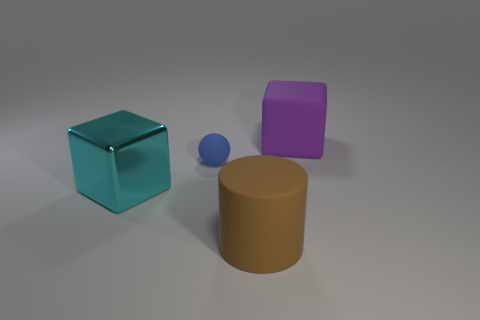Add 1 big brown matte objects. How many objects exist? 5 Subtract all cylinders. How many objects are left? 3 Add 4 big purple cubes. How many big purple cubes exist? 5 Subtract 0 blue blocks. How many objects are left? 4 Subtract all tiny matte balls. Subtract all cylinders. How many objects are left? 2 Add 4 big purple things. How many big purple things are left? 5 